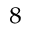Convert formula to latex. <formula><loc_0><loc_0><loc_500><loc_500>^ { 8 }</formula> 